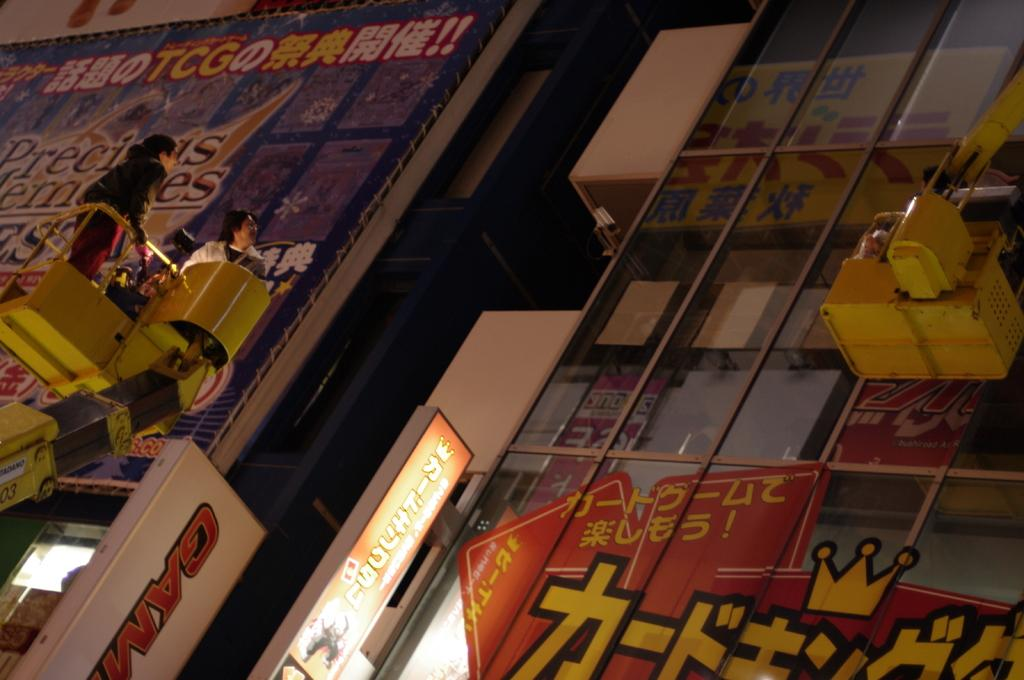<image>
Write a terse but informative summary of the picture. City billboards that say precious nemesis on them. 